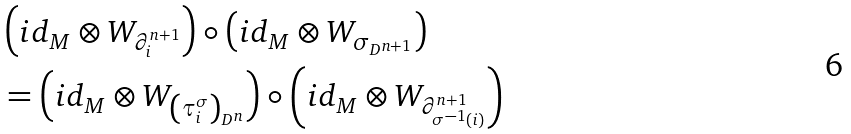<formula> <loc_0><loc_0><loc_500><loc_500>& \left ( i d _ { M } \otimes W _ { \partial _ { i } ^ { n + 1 } } \right ) \circ \left ( i d _ { M } \otimes W _ { \sigma _ { D ^ { n + 1 } } } \right ) \\ & = \left ( i d _ { M } \otimes W _ { \left ( \tau _ { i } ^ { \sigma } \right ) _ { D ^ { n } } } \right ) \circ \left ( i d _ { M } \otimes W _ { \partial _ { \sigma ^ { - 1 } ( i ) } ^ { n + 1 } } \right )</formula> 